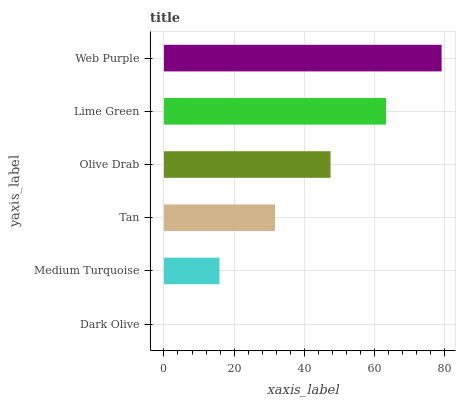Is Dark Olive the minimum?
Answer yes or no. Yes. Is Web Purple the maximum?
Answer yes or no. Yes. Is Medium Turquoise the minimum?
Answer yes or no. No. Is Medium Turquoise the maximum?
Answer yes or no. No. Is Medium Turquoise greater than Dark Olive?
Answer yes or no. Yes. Is Dark Olive less than Medium Turquoise?
Answer yes or no. Yes. Is Dark Olive greater than Medium Turquoise?
Answer yes or no. No. Is Medium Turquoise less than Dark Olive?
Answer yes or no. No. Is Olive Drab the high median?
Answer yes or no. Yes. Is Tan the low median?
Answer yes or no. Yes. Is Medium Turquoise the high median?
Answer yes or no. No. Is Lime Green the low median?
Answer yes or no. No. 